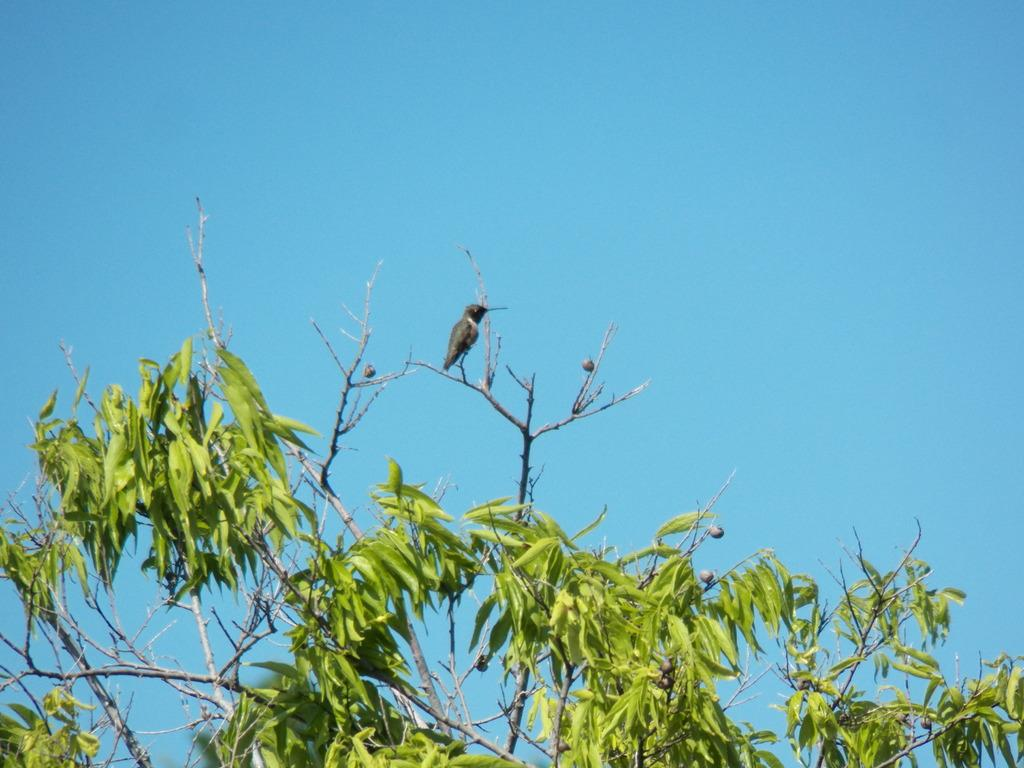What animal can be seen in the image? There is a bird in the image. Where is the bird located? The bird is standing on a branch. What is the branch like? The branch has leaves and fruits. What can be seen in the background of the image? There is a sky visible in the background of the image. What type of mitten is the bird wearing in the image? There is no mitten present in the image; the bird is standing on a branch with leaves and fruits. 